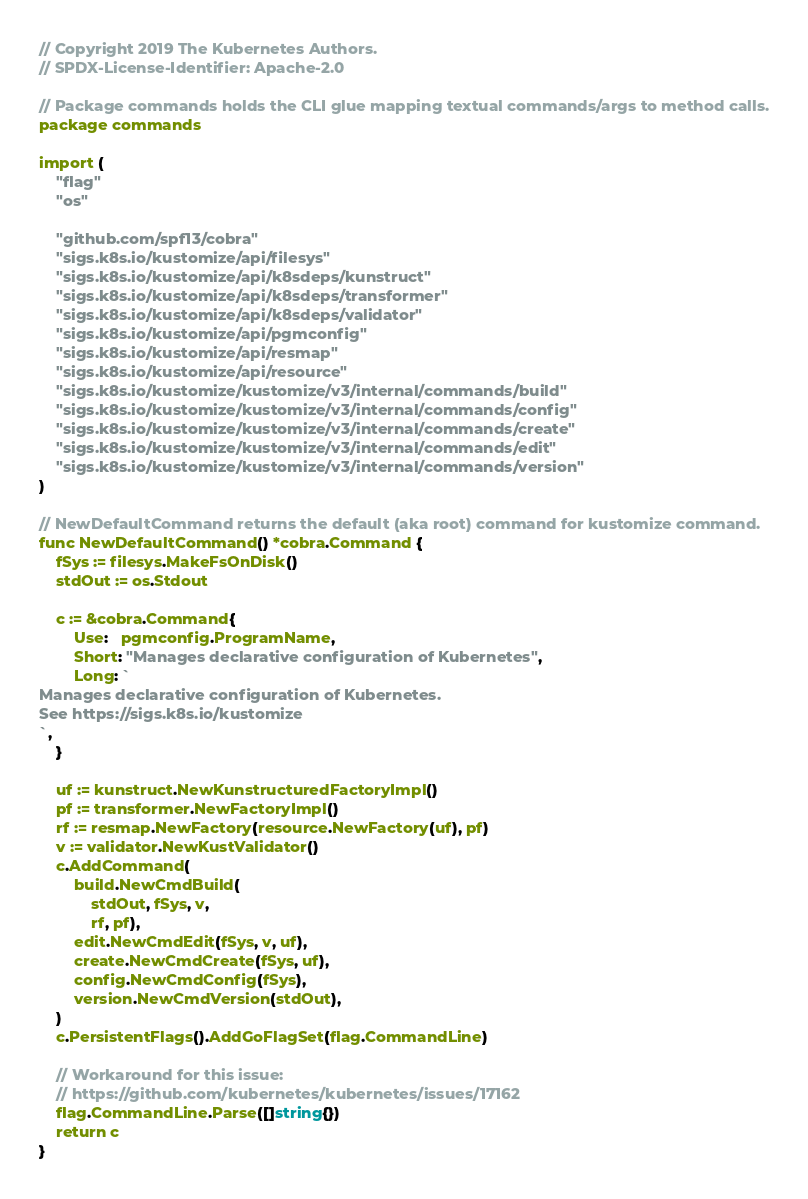Convert code to text. <code><loc_0><loc_0><loc_500><loc_500><_Go_>// Copyright 2019 The Kubernetes Authors.
// SPDX-License-Identifier: Apache-2.0

// Package commands holds the CLI glue mapping textual commands/args to method calls.
package commands

import (
	"flag"
	"os"

	"github.com/spf13/cobra"
	"sigs.k8s.io/kustomize/api/filesys"
	"sigs.k8s.io/kustomize/api/k8sdeps/kunstruct"
	"sigs.k8s.io/kustomize/api/k8sdeps/transformer"
	"sigs.k8s.io/kustomize/api/k8sdeps/validator"
	"sigs.k8s.io/kustomize/api/pgmconfig"
	"sigs.k8s.io/kustomize/api/resmap"
	"sigs.k8s.io/kustomize/api/resource"
	"sigs.k8s.io/kustomize/kustomize/v3/internal/commands/build"
	"sigs.k8s.io/kustomize/kustomize/v3/internal/commands/config"
	"sigs.k8s.io/kustomize/kustomize/v3/internal/commands/create"
	"sigs.k8s.io/kustomize/kustomize/v3/internal/commands/edit"
	"sigs.k8s.io/kustomize/kustomize/v3/internal/commands/version"
)

// NewDefaultCommand returns the default (aka root) command for kustomize command.
func NewDefaultCommand() *cobra.Command {
	fSys := filesys.MakeFsOnDisk()
	stdOut := os.Stdout

	c := &cobra.Command{
		Use:   pgmconfig.ProgramName,
		Short: "Manages declarative configuration of Kubernetes",
		Long: `
Manages declarative configuration of Kubernetes.
See https://sigs.k8s.io/kustomize
`,
	}

	uf := kunstruct.NewKunstructuredFactoryImpl()
	pf := transformer.NewFactoryImpl()
	rf := resmap.NewFactory(resource.NewFactory(uf), pf)
	v := validator.NewKustValidator()
	c.AddCommand(
		build.NewCmdBuild(
			stdOut, fSys, v,
			rf, pf),
		edit.NewCmdEdit(fSys, v, uf),
		create.NewCmdCreate(fSys, uf),
		config.NewCmdConfig(fSys),
		version.NewCmdVersion(stdOut),
	)
	c.PersistentFlags().AddGoFlagSet(flag.CommandLine)

	// Workaround for this issue:
	// https://github.com/kubernetes/kubernetes/issues/17162
	flag.CommandLine.Parse([]string{})
	return c
}
</code> 